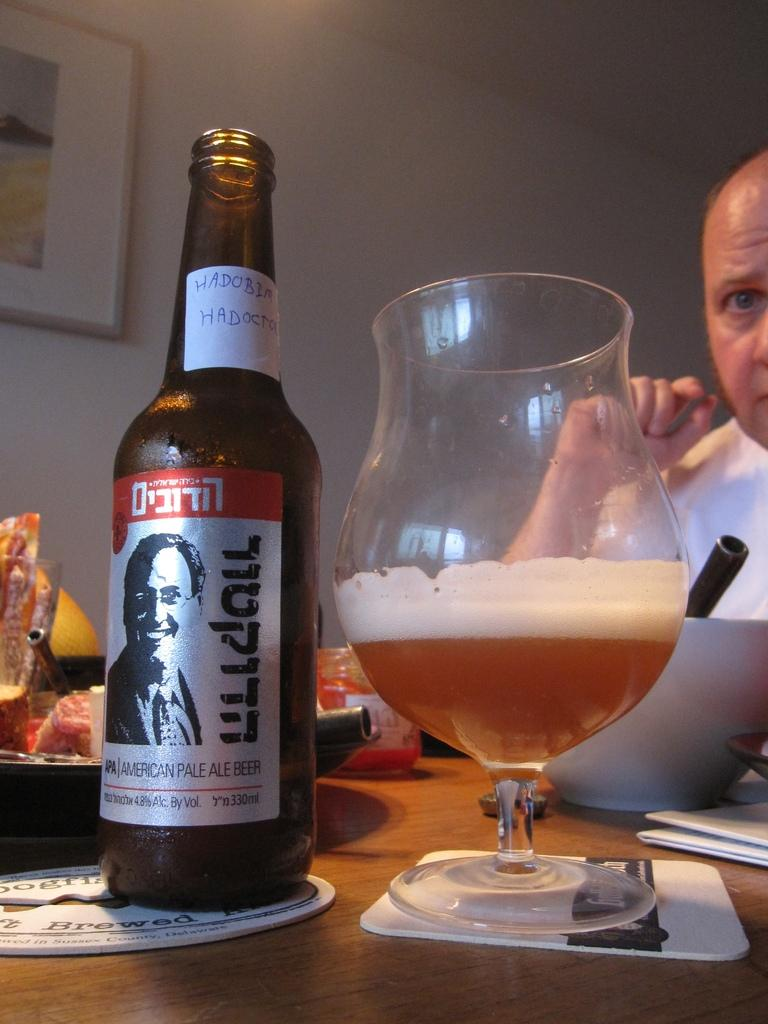<image>
Render a clear and concise summary of the photo. A man eating at a dinner table and drinking an American Pale Ale beer. 